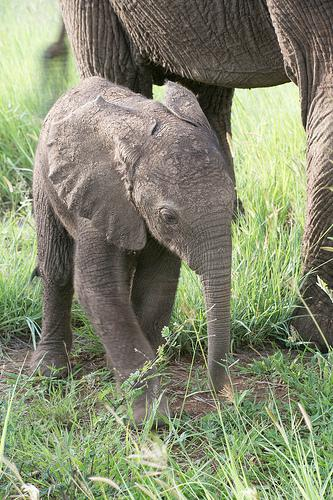Question: what is the elephants standing in?
Choices:
A. Mud.
B. Water.
C. Grass.
D. Snow.
Answer with the letter. Answer: C Question: who is walking?
Choices:
A. The baby.
B. The boy.
C. The girl.
D. The man.
Answer with the letter. Answer: A Question: how many elephants?
Choices:
A. Two.
B. Four.
C. Six.
D. Eight.
Answer with the letter. Answer: A Question: what color are the elephants?
Choices:
A. White.
B. Pink.
C. Gray.
D. Blue.
Answer with the letter. Answer: C 